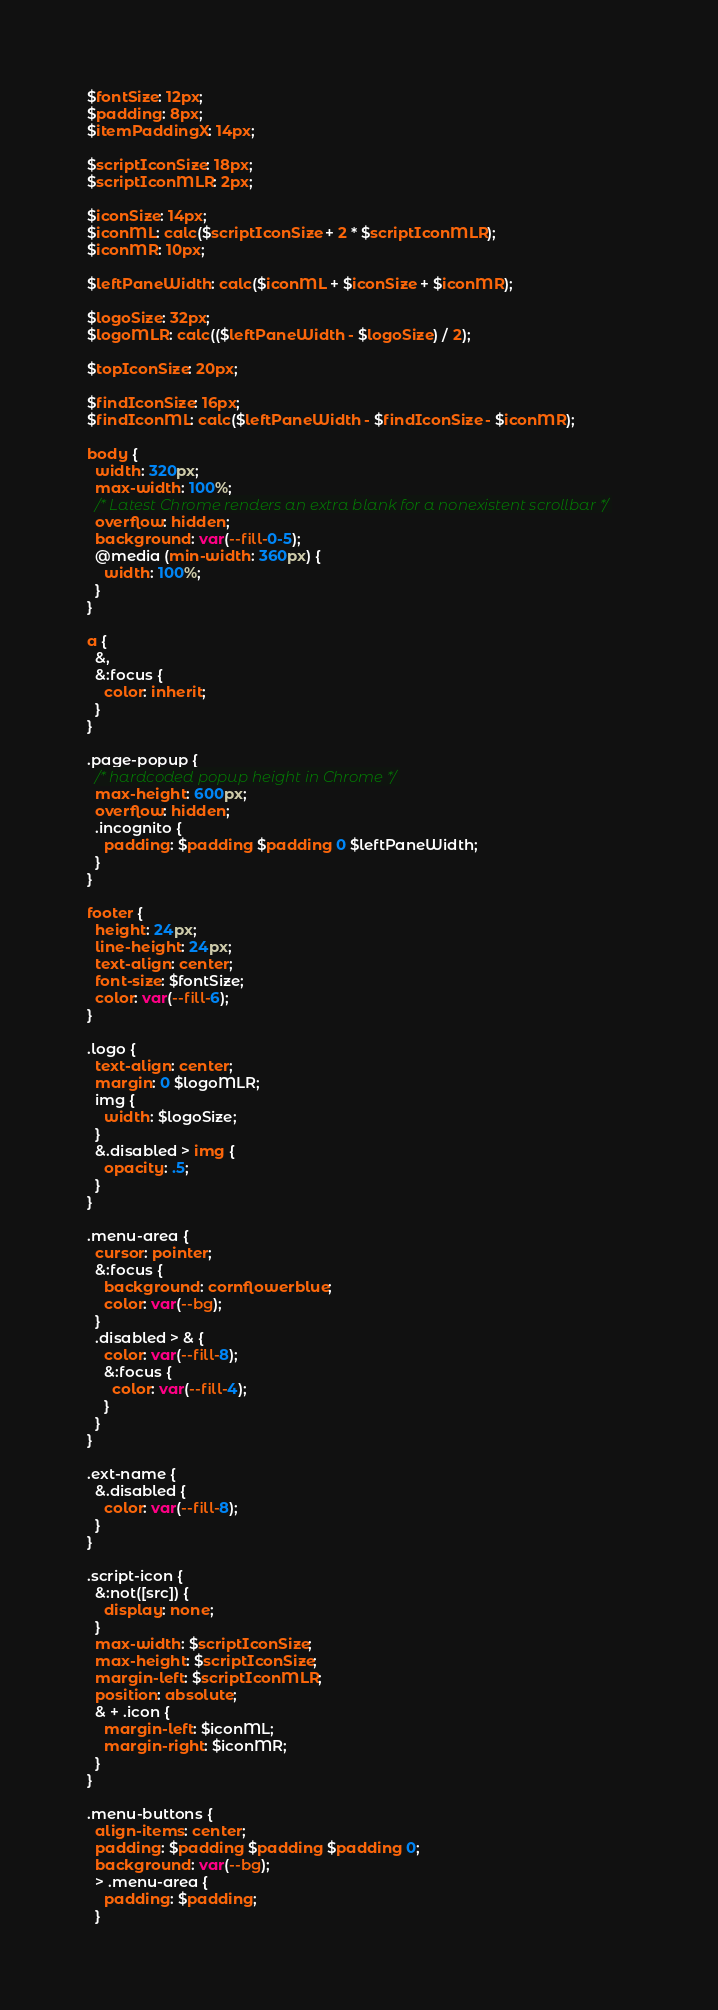<code> <loc_0><loc_0><loc_500><loc_500><_CSS_>$fontSize: 12px;
$padding: 8px;
$itemPaddingX: 14px;

$scriptIconSize: 18px;
$scriptIconMLR: 2px;

$iconSize: 14px;
$iconML: calc($scriptIconSize + 2 * $scriptIconMLR);
$iconMR: 10px;

$leftPaneWidth: calc($iconML + $iconSize + $iconMR);

$logoSize: 32px;
$logoMLR: calc(($leftPaneWidth - $logoSize) / 2);

$topIconSize: 20px;

$findIconSize: 16px;
$findIconML: calc($leftPaneWidth - $findIconSize - $iconMR);

body {
  width: 320px;
  max-width: 100%;
  /* Latest Chrome renders an extra blank for a nonexistent scrollbar */
  overflow: hidden;
  background: var(--fill-0-5);
  @media (min-width: 360px) {
    width: 100%;
  }
}

a {
  &,
  &:focus {
    color: inherit;
  }
}

.page-popup {
  /* hardcoded popup height in Chrome */
  max-height: 600px;
  overflow: hidden;
  .incognito {
    padding: $padding $padding 0 $leftPaneWidth;
  }
}

footer {
  height: 24px;
  line-height: 24px;
  text-align: center;
  font-size: $fontSize;
  color: var(--fill-6);
}

.logo {
  text-align: center;
  margin: 0 $logoMLR;
  img {
    width: $logoSize;
  }
  &.disabled > img {
    opacity: .5;
  }
}

.menu-area {
  cursor: pointer;
  &:focus {
    background: cornflowerblue;
    color: var(--bg);
  }
  .disabled > & {
    color: var(--fill-8);
    &:focus {
      color: var(--fill-4);
    }
  }
}

.ext-name {
  &.disabled {
    color: var(--fill-8);
  }
}

.script-icon {
  &:not([src]) {
    display: none;
  }
  max-width: $scriptIconSize;
  max-height: $scriptIconSize;
  margin-left: $scriptIconMLR;
  position: absolute;
  & + .icon {
    margin-left: $iconML;
    margin-right: $iconMR;
  }
}

.menu-buttons {
  align-items: center;
  padding: $padding $padding $padding 0;
  background: var(--bg);
  > .menu-area {
    padding: $padding;
  }</code> 